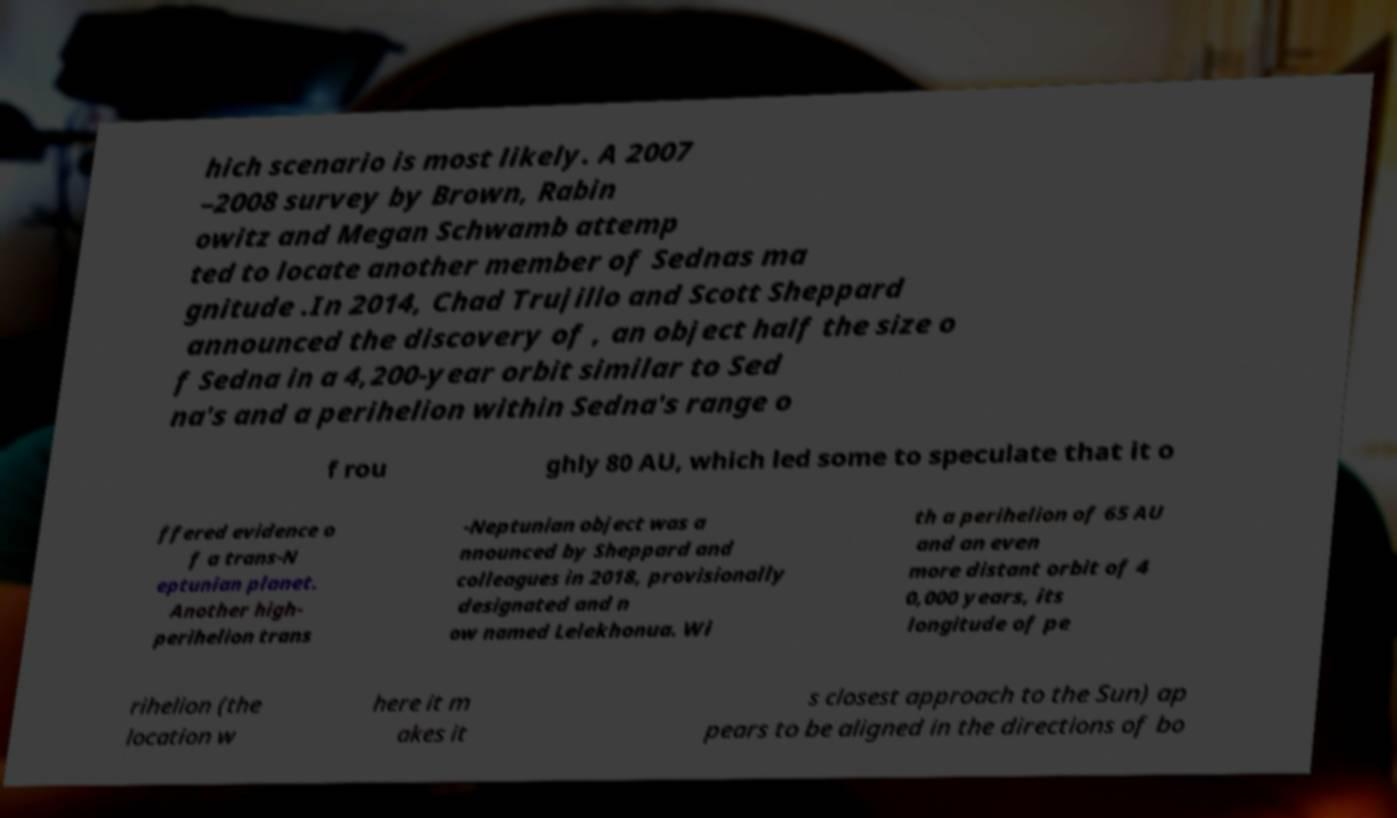Could you extract and type out the text from this image? hich scenario is most likely. A 2007 –2008 survey by Brown, Rabin owitz and Megan Schwamb attemp ted to locate another member of Sednas ma gnitude .In 2014, Chad Trujillo and Scott Sheppard announced the discovery of , an object half the size o f Sedna in a 4,200-year orbit similar to Sed na's and a perihelion within Sedna's range o f rou ghly 80 AU, which led some to speculate that it o ffered evidence o f a trans-N eptunian planet. Another high- perihelion trans -Neptunian object was a nnounced by Sheppard and colleagues in 2018, provisionally designated and n ow named Lelekhonua. Wi th a perihelion of 65 AU and an even more distant orbit of 4 0,000 years, its longitude of pe rihelion (the location w here it m akes it s closest approach to the Sun) ap pears to be aligned in the directions of bo 